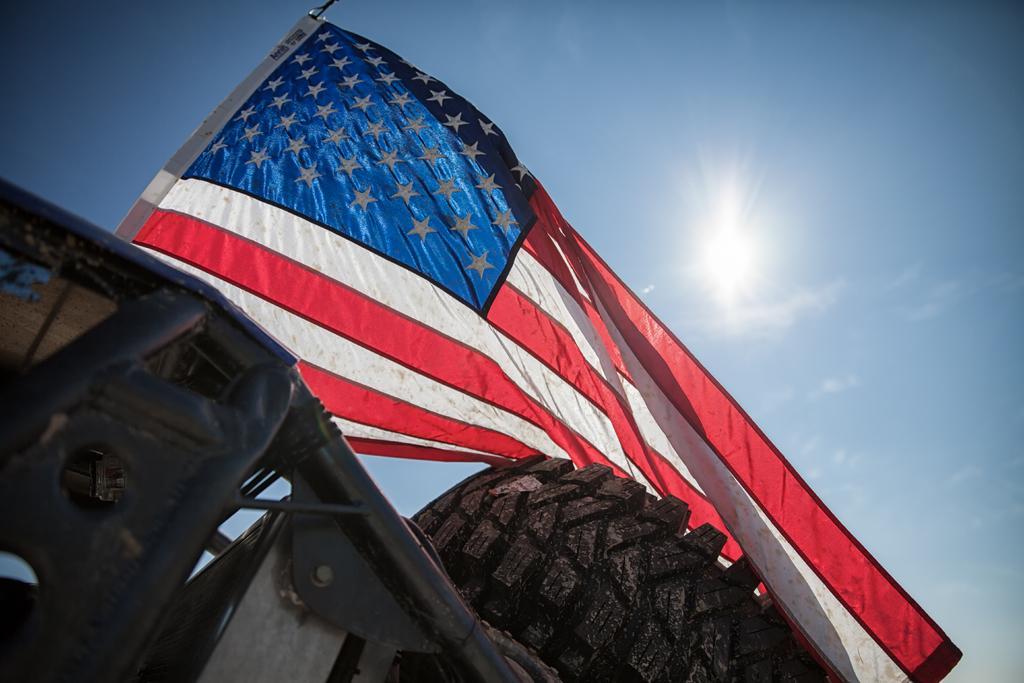In one or two sentences, can you explain what this image depicts? In this image there is a vehicle and we can see a flag. In the background there is sky. 